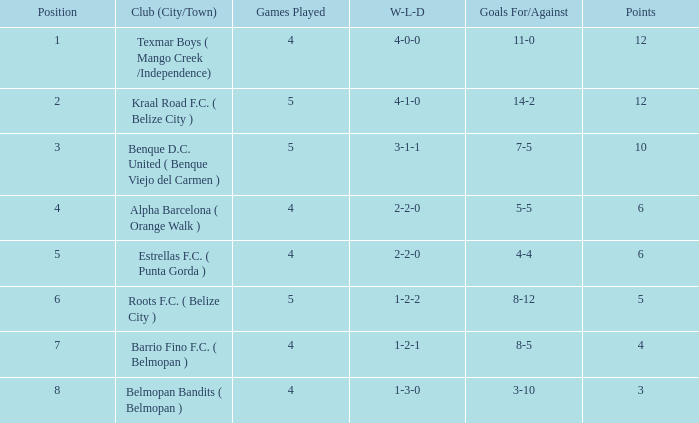With a score of 7-5 for/against, what is the minimum number of games that have been played? 5.0. 